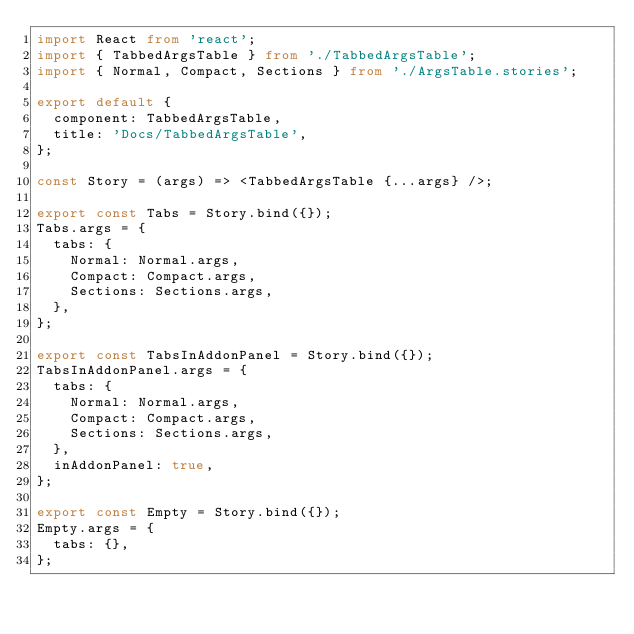Convert code to text. <code><loc_0><loc_0><loc_500><loc_500><_TypeScript_>import React from 'react';
import { TabbedArgsTable } from './TabbedArgsTable';
import { Normal, Compact, Sections } from './ArgsTable.stories';

export default {
  component: TabbedArgsTable,
  title: 'Docs/TabbedArgsTable',
};

const Story = (args) => <TabbedArgsTable {...args} />;

export const Tabs = Story.bind({});
Tabs.args = {
  tabs: {
    Normal: Normal.args,
    Compact: Compact.args,
    Sections: Sections.args,
  },
};

export const TabsInAddonPanel = Story.bind({});
TabsInAddonPanel.args = {
  tabs: {
    Normal: Normal.args,
    Compact: Compact.args,
    Sections: Sections.args,
  },
  inAddonPanel: true,
};

export const Empty = Story.bind({});
Empty.args = {
  tabs: {},
};
</code> 